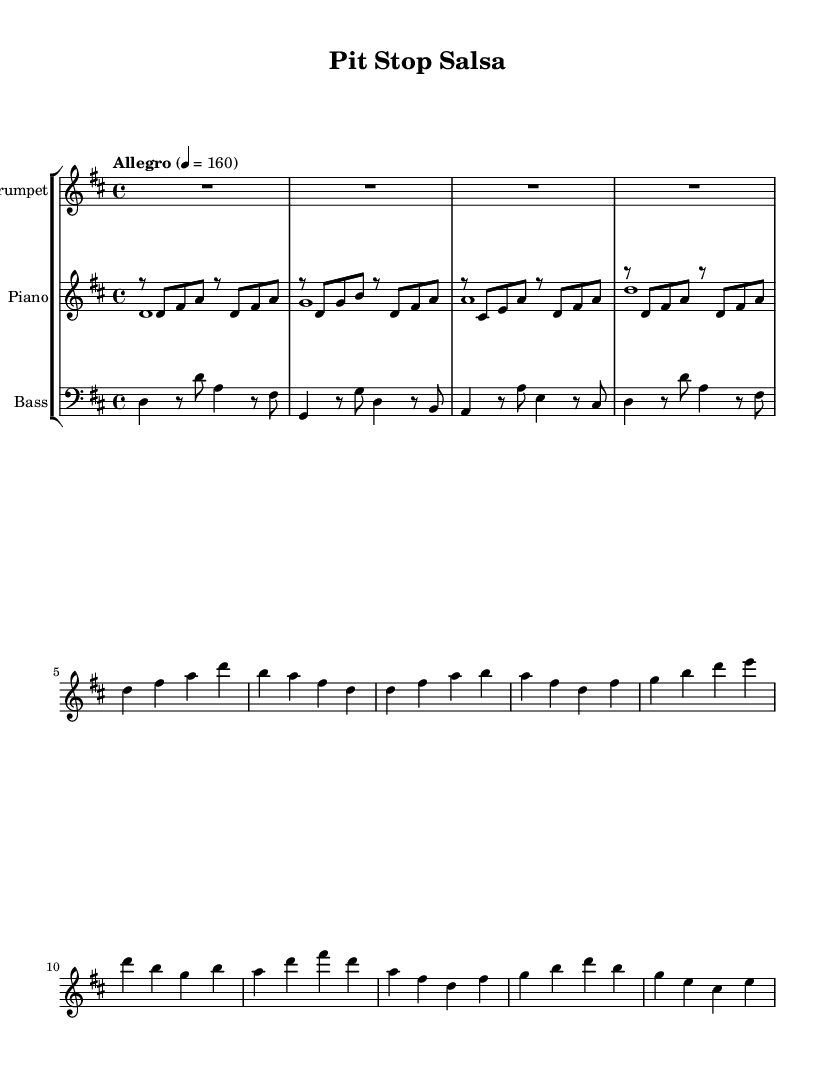What is the key signature of this music? The music is in D major, which has two sharps (F# and C#) indicated in the key signature at the beginning of the sheet.
Answer: D major What is the time signature of this piece? The time signature is 4/4, which is represented at the beginning of the music. It indicates that there are four beats in a measure and the quarter note gets one count.
Answer: 4/4 What is the tempo marking of this composition? The tempo is indicated as "Allegro," which typically means a fast and lively pace. The specific metronome marking given is 4 = 160, indicating the beats per minute.
Answer: Allegro How many measures are there in the trumpet part? Counting the segments in the trumpet line, there are a total of ten measures across the music. Each line or bar separated by the vertical line represents a measure.
Answer: 10 What is the rhythmic pattern primarily used in the piano part? The piano part predominantly features eighth notes followed by quarter notes, creating a syncopated rhythm that is characteristic of salsa music. This innovative rhythm enhances the overall groove of the piece.
Answer: Eighth and quarter notes Which instrument plays the lowest notes in this arrangement? The bass instrument plays the lowest notes in this musical arrangement, and it is positioned below the piano and trumpet. The bass's low register contributes to the harmonic foundation.
Answer: Bass 